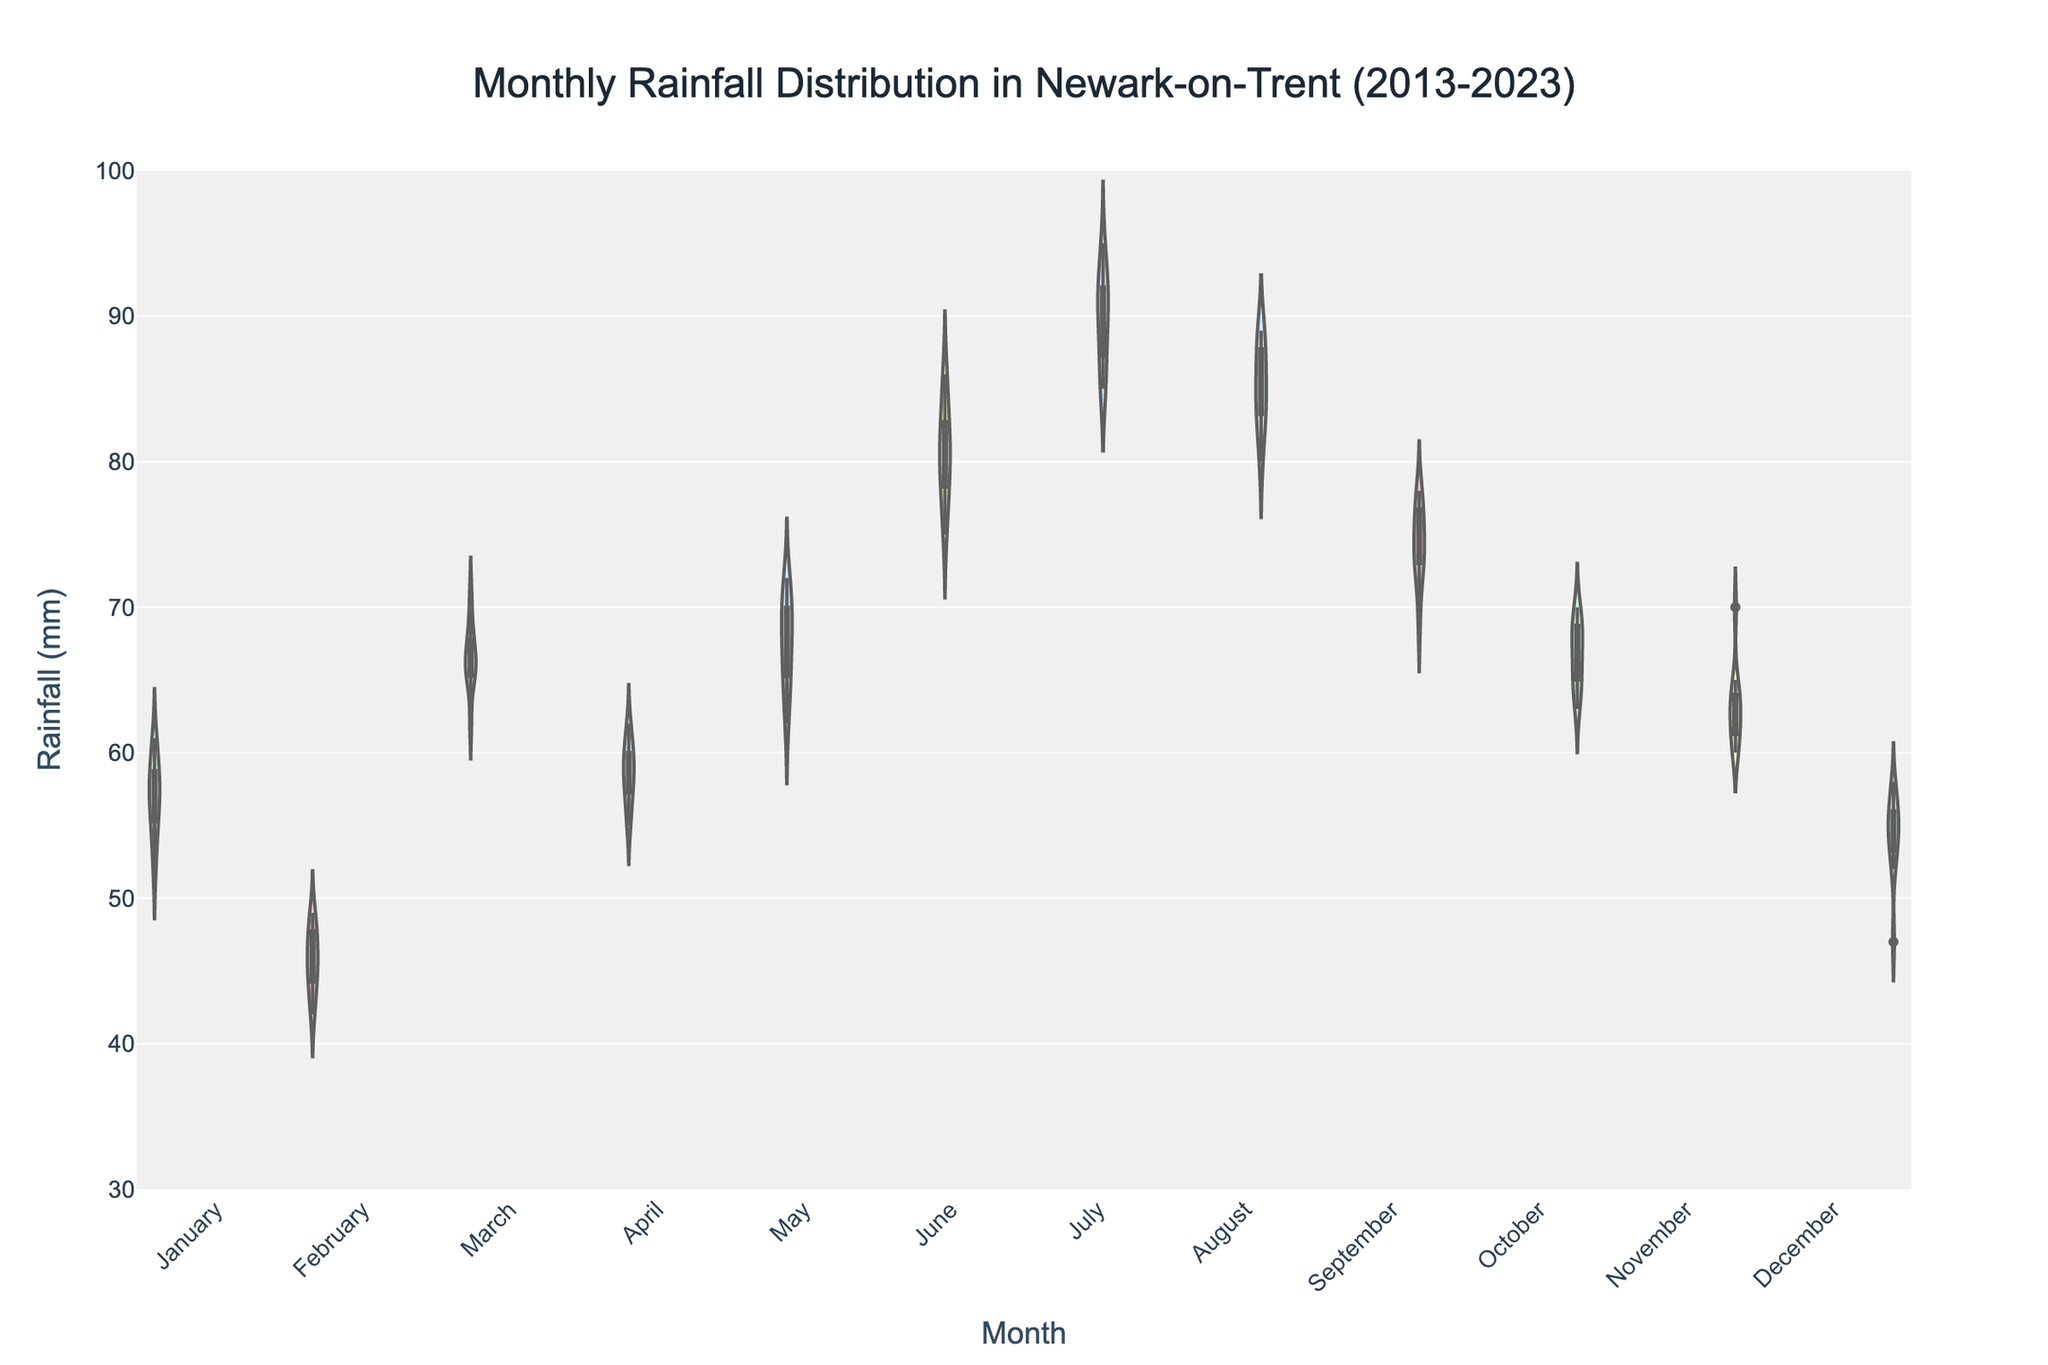Which month has the widest distribution of rainfall? To determine which month has the widest distribution of rainfall, look for the month where the width of the violin plot is the largest, indicating more variability in the data.
Answer: July What is the median rainfall for June? The median is indicated by the white bar inside the violin plot representation. For June, locate the white bar's position within the June segment on the y-axis.
Answer: Around 80 mm How does the mean rainfall in February compare to that in August? The mean is represented by a dashed line in the middle of the violin. Compare the position of these lines on the y-axis for both February and August.
Answer: February's mean rainfall is lower than August's mean rainfall Is there any month where the minimum observed rainfall is above 40 mm? Check the lowest point of each violin plot to see if any month has its minimum value above 40 mm on the y-axis.
Answer: Yes, all months have minimum rainfall above 40 mm Which months have the highest median rainfall? Find the white bars that represent the median for each month and identify which months have the highest positions on the y-axis.
Answer: July and August What can be said about the rainfall distribution in March across the decade? Observing the shape and spread of the violin plot for March, you can infer the variability, skewness, and central tendencies of the monthly rainfall throughout the decade.
Answer: March has a relatively symmetrical distribution with moderate variability How does the range of rainfall in November compare to that in June? The range is the difference between the highest and lowest points of the violin plot. Compare these ranges for November and June by observing the spread from top to bottom on the y-axis.
Answer: November's range is slightly smaller than June's range Which month is least likely to have extreme rainfall values? Identify the month with the narrowest range or the smallest spread in its violin plot, as this indicates fewer outliers and extreme values.
Answer: February What is the approximate interquartile range (IQR) for rainfall in October? The IQR is represented by the width of the violin plot between the first (bottom of the upper box) and third quartiles (top of the lower box). Observe this range on the y-axis for October.
Answer: Around 9 mm How does the interquartile range (IQR) of July compare with that of December? Compare the range between the first and third quartiles for July and December. Look at the width between the corresponding parts of their violin plots.
Answer: July's IQR is broader than December's IQR 